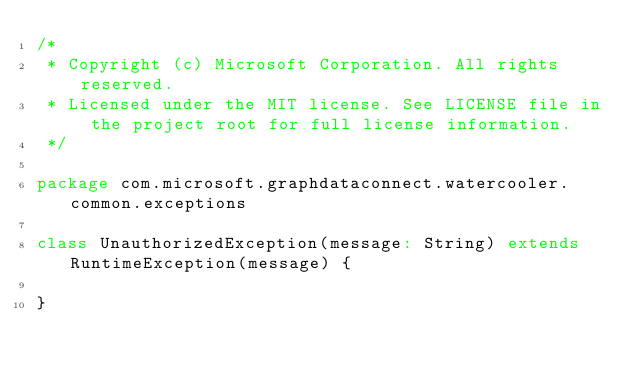Convert code to text. <code><loc_0><loc_0><loc_500><loc_500><_Scala_>/*
 * Copyright (c) Microsoft Corporation. All rights reserved.
 * Licensed under the MIT license. See LICENSE file in the project root for full license information.
 */

package com.microsoft.graphdataconnect.watercooler.common.exceptions

class UnauthorizedException(message: String) extends RuntimeException(message) {

}
</code> 